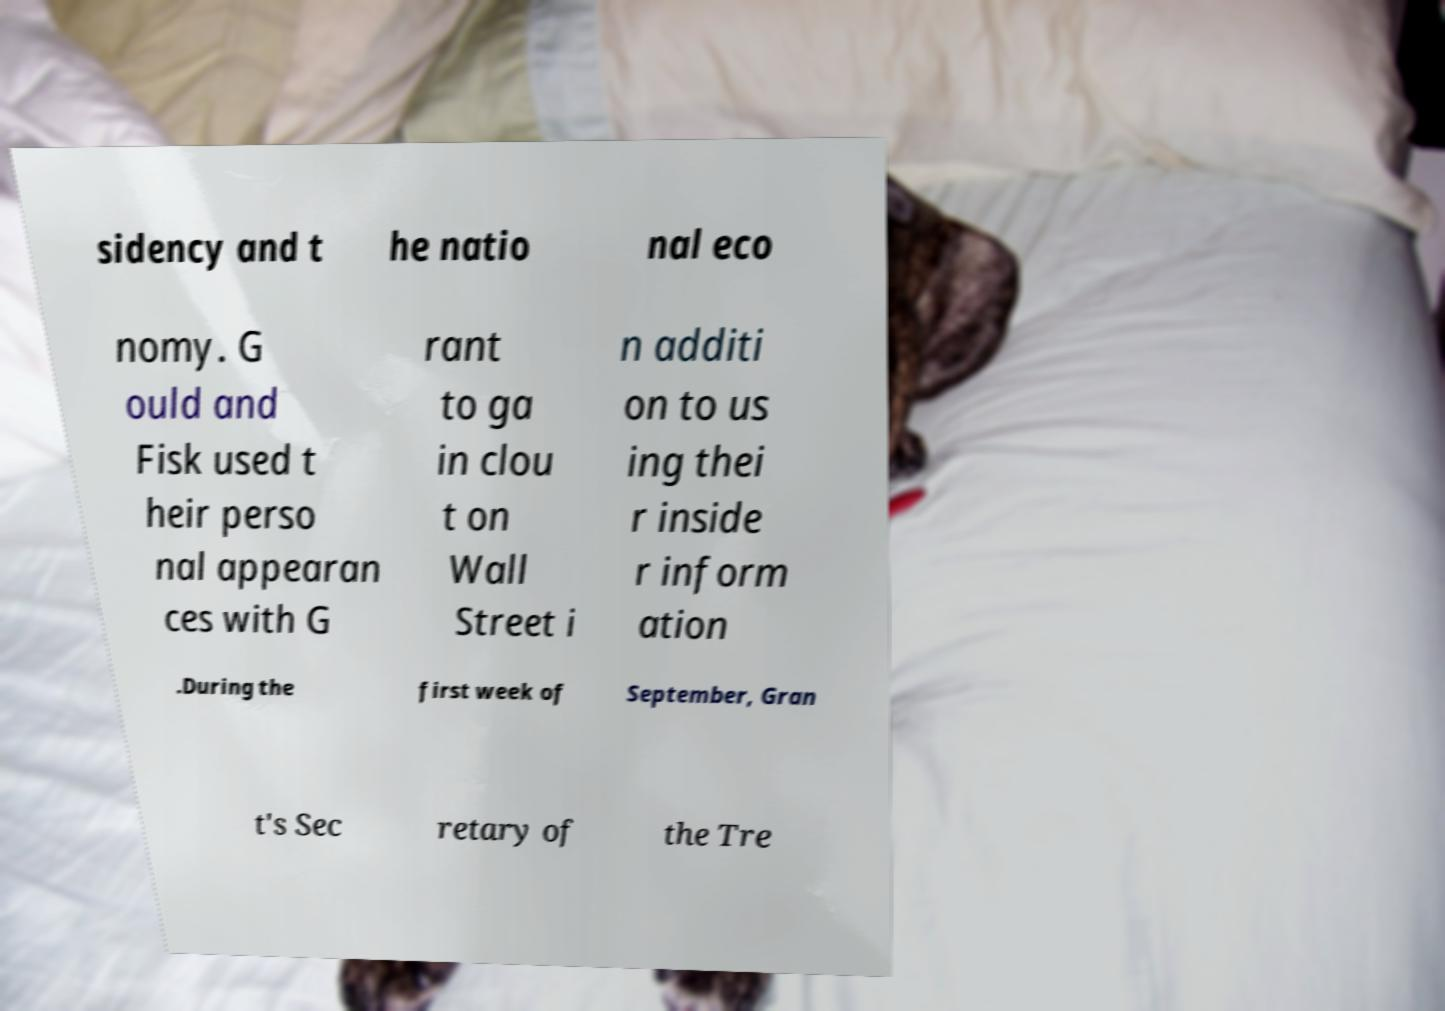I need the written content from this picture converted into text. Can you do that? sidency and t he natio nal eco nomy. G ould and Fisk used t heir perso nal appearan ces with G rant to ga in clou t on Wall Street i n additi on to us ing thei r inside r inform ation .During the first week of September, Gran t's Sec retary of the Tre 